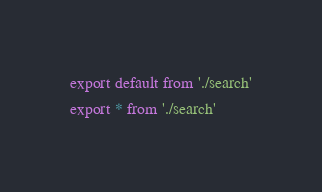Convert code to text. <code><loc_0><loc_0><loc_500><loc_500><_JavaScript_>export default from './search'
export * from './search'
</code> 